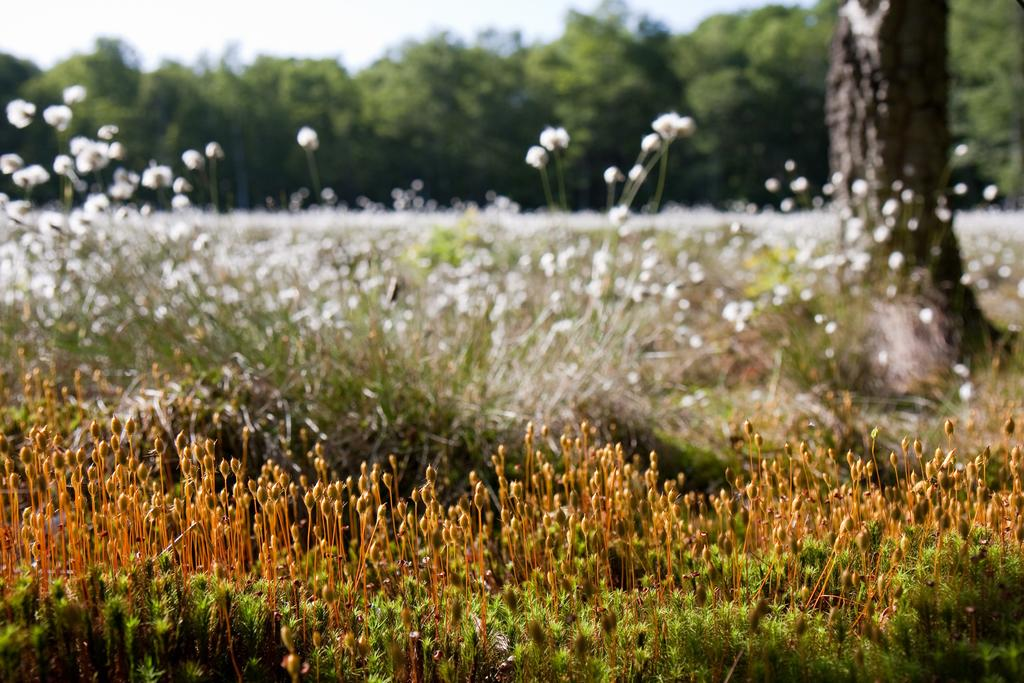What type of vegetation is present in the image? There are many plants in the image, including trees and cotton plants. Where are the cotton plants located in the image? The cotton plants are in the middle of the image. What can be seen in the background of the image? There are trees in the background of the image. What is visible at the top of the image? The sky is visible at the top of the image. Can you see the moon in the image? No, the moon is not visible in the image; only the sky is visible at the top of the image. 